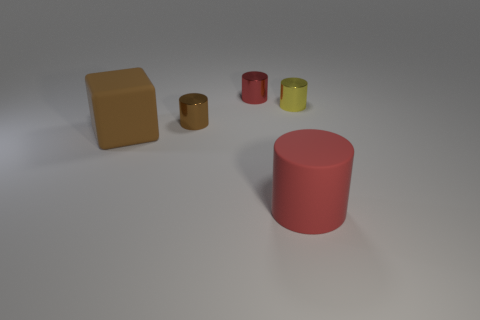Subtract all yellow metal cylinders. How many cylinders are left? 3 Add 3 blue rubber objects. How many objects exist? 8 Subtract all yellow spheres. How many red cylinders are left? 2 Subtract all red cylinders. How many cylinders are left? 2 Subtract 1 brown cubes. How many objects are left? 4 Subtract all cylinders. How many objects are left? 1 Subtract 2 cylinders. How many cylinders are left? 2 Subtract all yellow cylinders. Subtract all yellow blocks. How many cylinders are left? 3 Subtract all rubber cubes. Subtract all yellow metallic cylinders. How many objects are left? 3 Add 2 small metal cylinders. How many small metal cylinders are left? 5 